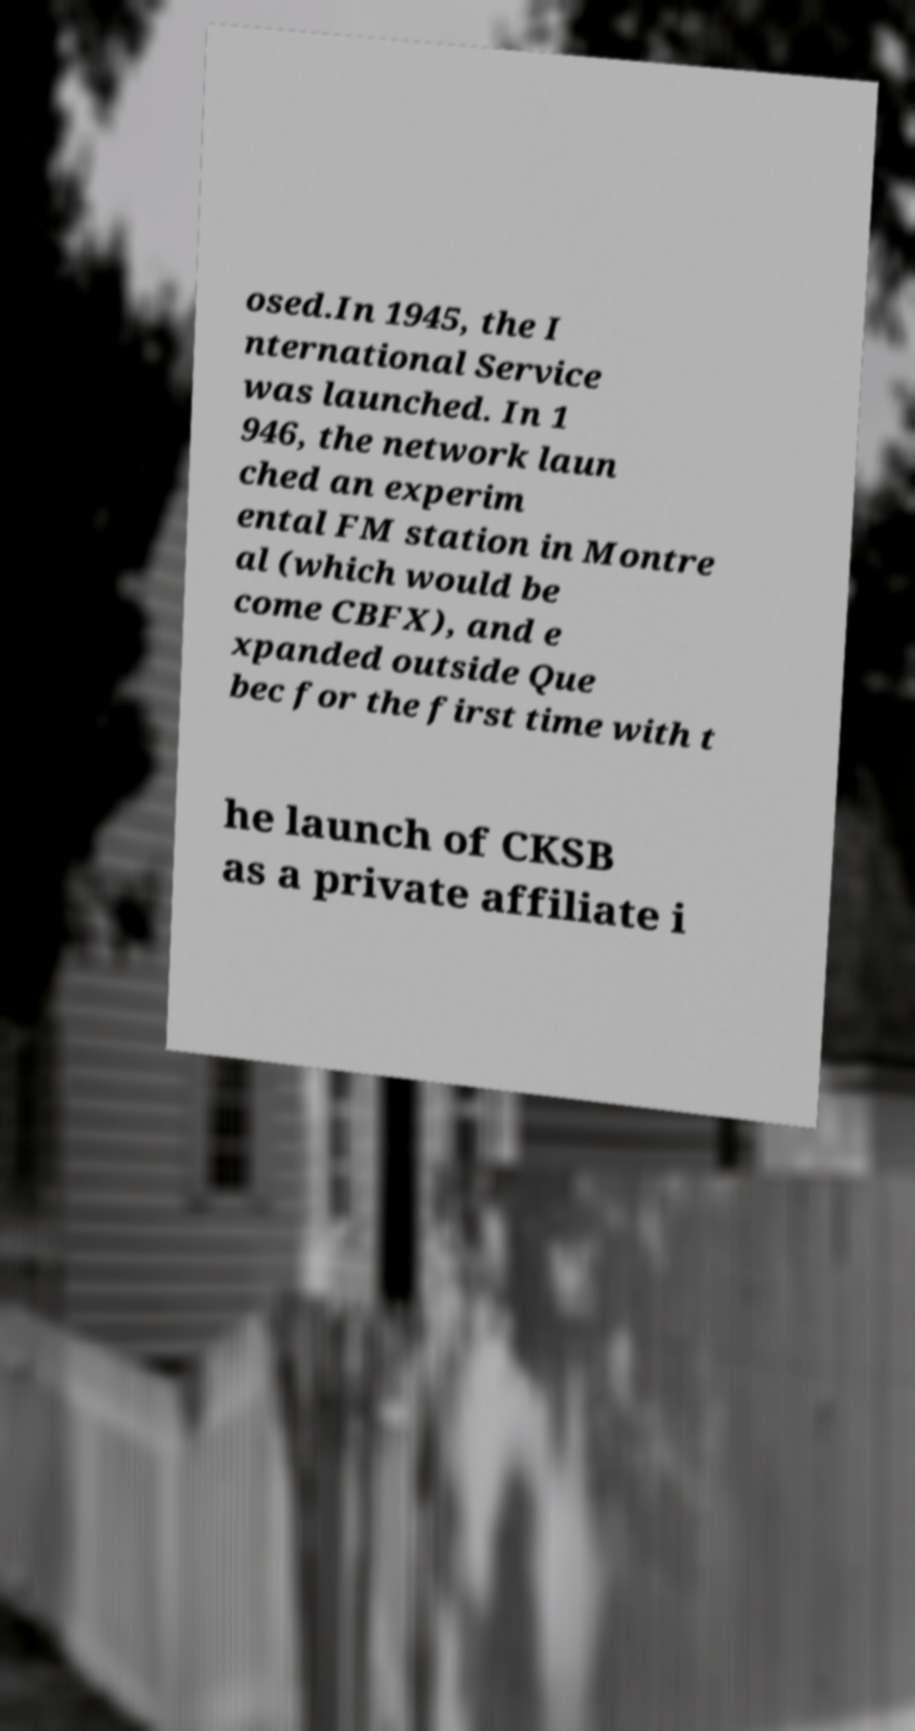Can you accurately transcribe the text from the provided image for me? osed.In 1945, the I nternational Service was launched. In 1 946, the network laun ched an experim ental FM station in Montre al (which would be come CBFX), and e xpanded outside Que bec for the first time with t he launch of CKSB as a private affiliate i 